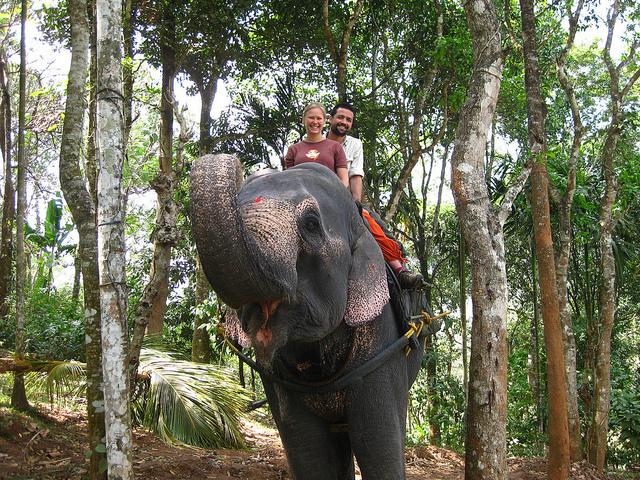How many people are sitting on the elephant?
Be succinct. 2. How many people are on the elephant?
Write a very short answer. 2. Are these people riding an elephant at a circus?
Keep it brief. No. What are the people riding?
Be succinct. Elephant. Is the man or woman driving?
Quick response, please. Woman. Where is the man and woman riding an elephant?
Be succinct. Forest. What color of shirt is the man on the elephant wearing?
Quick response, please. White. What are the people's hands placed on?
Concise answer only. Elephant. 